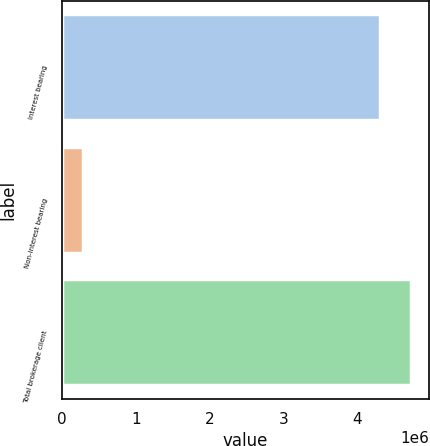Convert chart to OTSL. <chart><loc_0><loc_0><loc_500><loc_500><bar_chart><fcel>Interest bearing<fcel>Non-interest bearing<fcel>Total brokerage client<nl><fcel>4.29964e+06<fcel>285016<fcel>4.7296e+06<nl></chart> 